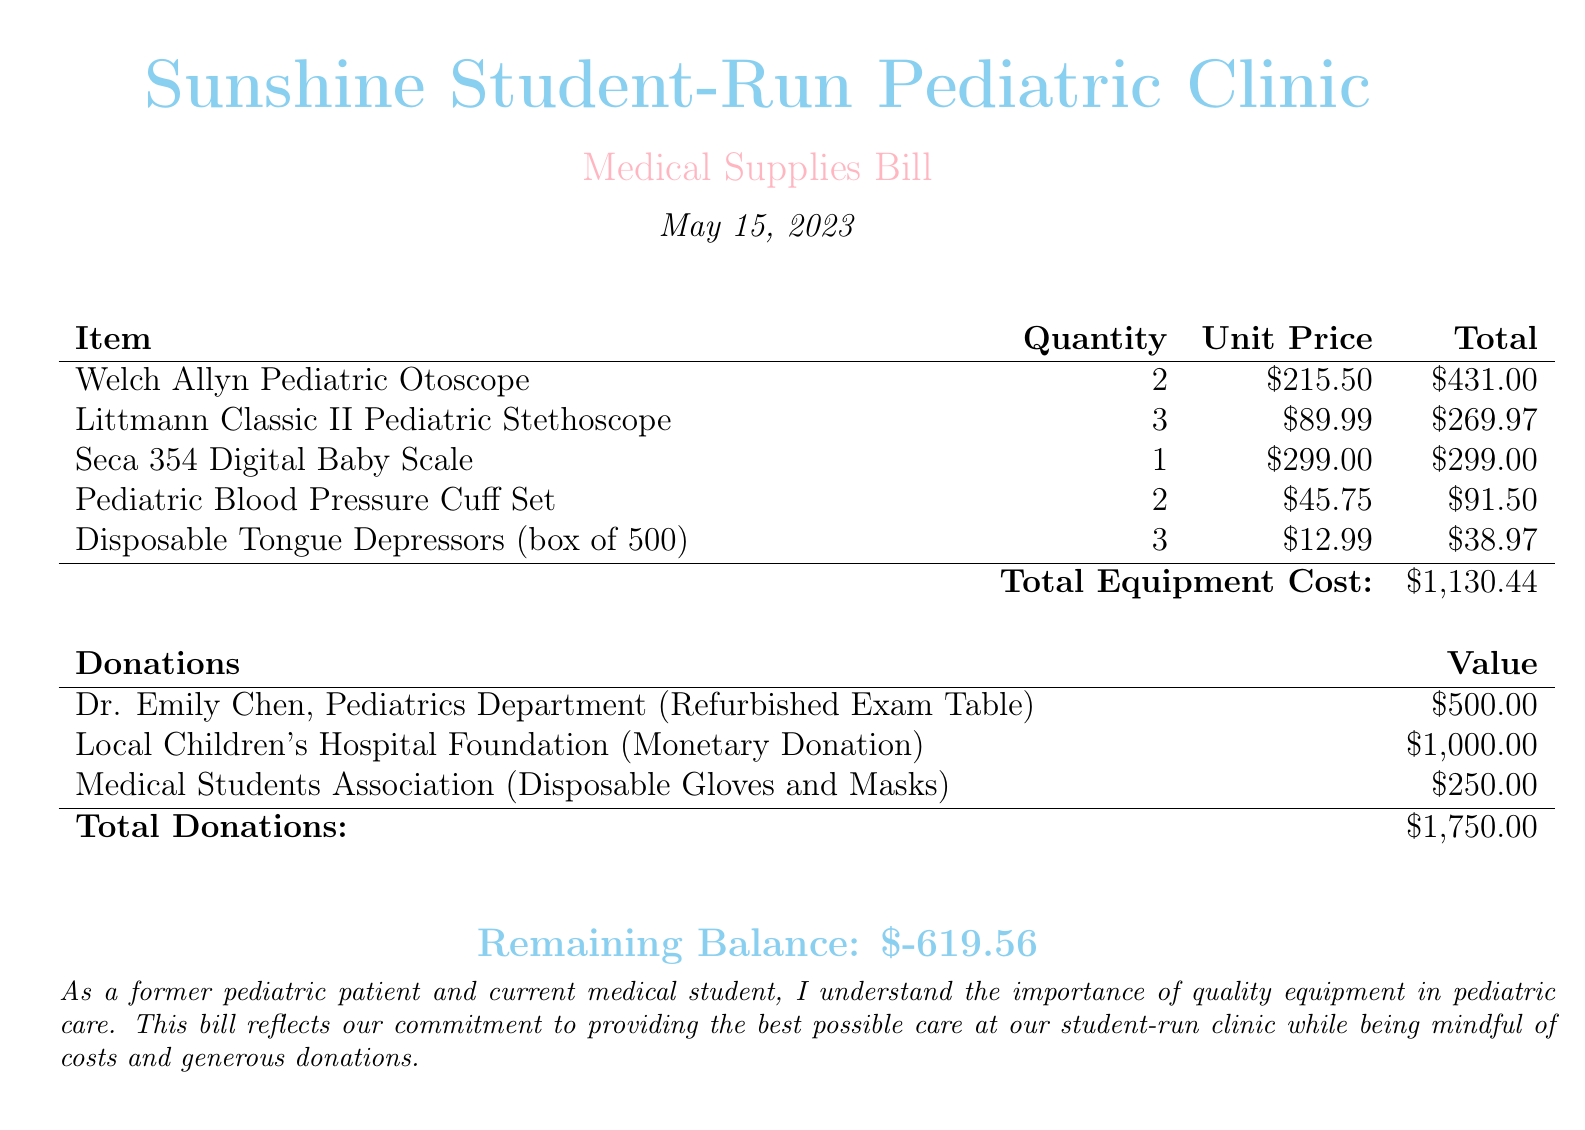What is the total equipment cost? The total equipment cost is indicated at the bottom of the equipment cost table.
Answer: $1,130.44 How many Pediatric Stethoscopes were ordered? The document lists the quantity of Littmann Classic II Pediatric Stethoscopes in the equipment table.
Answer: 3 What is the value of the monetary donation from the Local Children's Hospital Foundation? The value can be found in the donations table, reflecting the amount contributed.
Answer: $1,000.00 Who donated the refurbished exam table? The donor's name is mentioned in the donations section of the document.
Answer: Dr. Emily Chen What is the remaining balance? The remaining balance is calculated and displayed prominently at the bottom of the document.
Answer: $-619.56 How many Disposable Tongue Depressors were included in the order? The quantity is specified in the itemized equipment bill.
Answer: 3 What type of medical supplies were donated by the Medical Students Association? The donation details specify the nature of items contributed in the donations table.
Answer: Disposable Gloves and Masks What is the date of the bill? The date is located near the top of the document, under the clinic name and medical supplies bill title.
Answer: May 15, 2023 